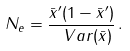Convert formula to latex. <formula><loc_0><loc_0><loc_500><loc_500>N _ { e } = \frac { \bar { x } ^ { \prime } ( 1 - \bar { x } ^ { \prime } ) } { \ V a r ( \bar { x } ) } \, .</formula> 